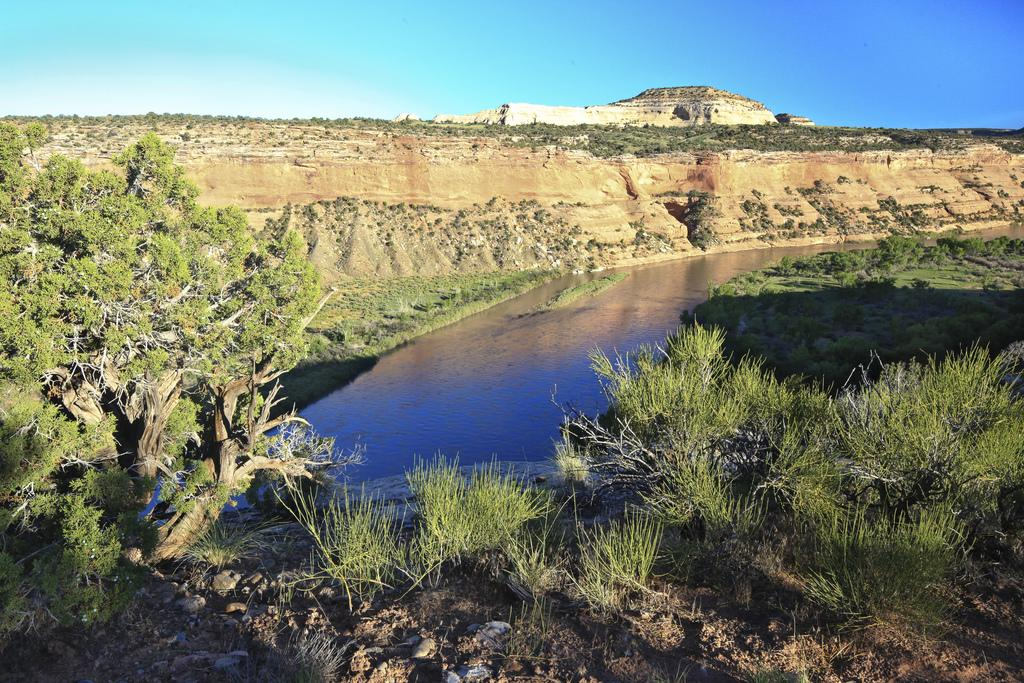What type of vegetation can be seen in the image? There are trees in the image. What natural feature is visible in the image? There is water visible in the image. What type of landscape is depicted in the image? There are hills in the image. What color is the sky in the background of the image? The sky is blue in the background of the image. Where is the jail located in the image? There is no jail present in the image. What type of rod is being used by the expert in the image? There is no expert or rod present in the image. 